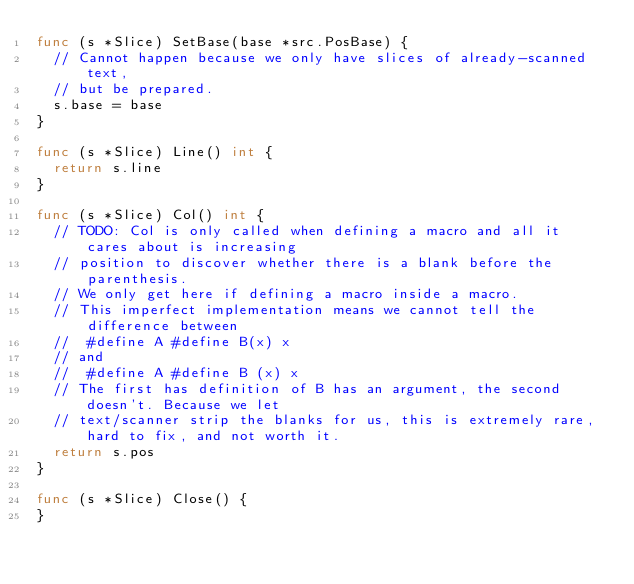Convert code to text. <code><loc_0><loc_0><loc_500><loc_500><_Go_>func (s *Slice) SetBase(base *src.PosBase) {
	// Cannot happen because we only have slices of already-scanned text,
	// but be prepared.
	s.base = base
}

func (s *Slice) Line() int {
	return s.line
}

func (s *Slice) Col() int {
	// TODO: Col is only called when defining a macro and all it cares about is increasing
	// position to discover whether there is a blank before the parenthesis.
	// We only get here if defining a macro inside a macro.
	// This imperfect implementation means we cannot tell the difference between
	//	#define A #define B(x) x
	// and
	//	#define A #define B (x) x
	// The first has definition of B has an argument, the second doesn't. Because we let
	// text/scanner strip the blanks for us, this is extremely rare, hard to fix, and not worth it.
	return s.pos
}

func (s *Slice) Close() {
}
</code> 